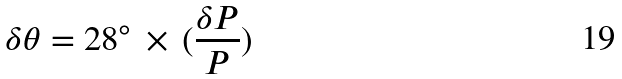Convert formula to latex. <formula><loc_0><loc_0><loc_500><loc_500>\delta \theta = 2 8 ^ { \circ } \, \times \, ( \frac { \delta P } { P } )</formula> 